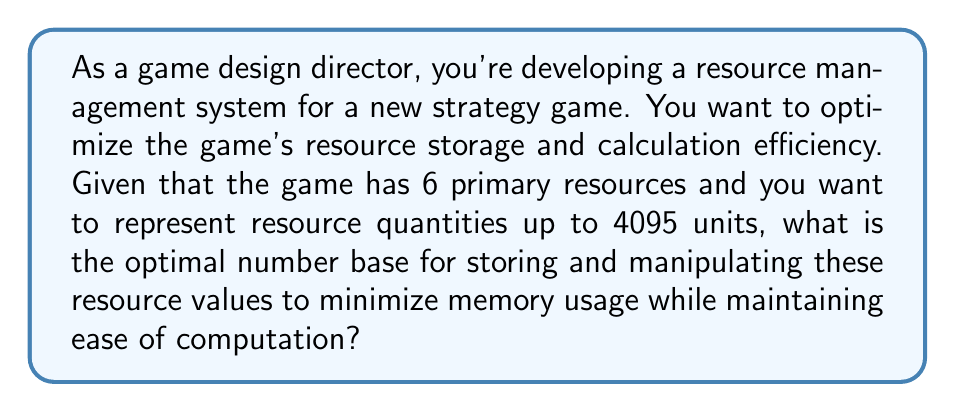Help me with this question. To determine the optimal number base, we need to consider the following factors:

1. Number of primary resources: 6
2. Maximum resource quantity: 4095

Step 1: Determine the minimum number of digits required to represent 4095 in different bases.

Let's calculate this for bases 2 through 16:

Base 2: $\log_2(4095) \approx 11.99$, so 12 digits are needed.
Base 3: $\log_3(4095) \approx 7.57$, so 8 digits are needed.
Base 4: $\log_4(4095) \approx 5.99$, so 6 digits are needed.
Base 5: $\log_5(4095) \approx 5.12$, so 6 digits are needed.
Base 6: $\log_6(4095) \approx 4.55$, so 5 digits are needed.
Base 7: $\log_7(4095) \approx 4.14$, so 5 digits are needed.
Base 8: $\log_8(4095) \approx 3.83$, so 4 digits are needed.
Bases 9-16: 4 digits are needed.

Step 2: Consider the number of primary resources (6).

The optimal base should be able to represent all 6 resources efficiently. Base 6 is a natural choice as it directly corresponds to the number of resources.

Step 3: Evaluate efficiency and ease of computation.

While base 8 (octal) or base 16 (hexadecimal) might seem attractive due to their relation to binary (2^3 and 2^4 respectively), base 6 offers a good balance between efficiency and ease of computation for this specific game scenario.

Using base 6:
- Each digit can represent 0-5, corresponding directly to the 6 primary resources.
- 5 digits in base 6 can represent up to $6^5 - 1 = 7775$ units, which is sufficient for the maximum of 4095.
- Calculations can be performed digit by digit, with each digit corresponding to a specific resource.

Therefore, base 6 is the optimal choice for this game's resource management system.
Answer: The optimal number base for efficient game resource management in this scenario is 6 (base-6 or senary number system). 